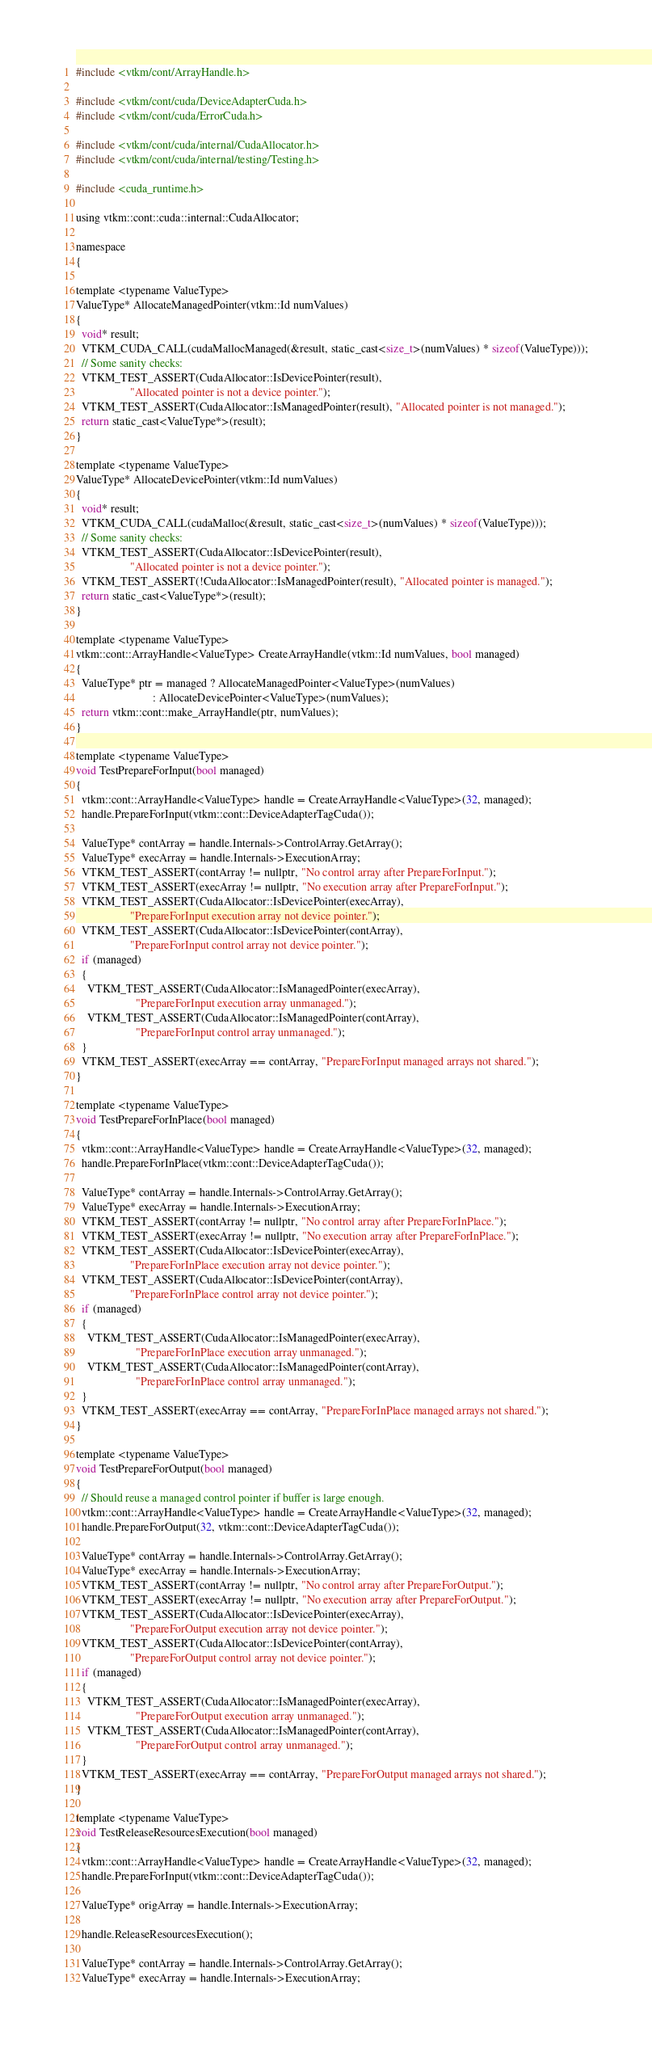Convert code to text. <code><loc_0><loc_0><loc_500><loc_500><_Cuda_>#include <vtkm/cont/ArrayHandle.h>

#include <vtkm/cont/cuda/DeviceAdapterCuda.h>
#include <vtkm/cont/cuda/ErrorCuda.h>

#include <vtkm/cont/cuda/internal/CudaAllocator.h>
#include <vtkm/cont/cuda/internal/testing/Testing.h>

#include <cuda_runtime.h>

using vtkm::cont::cuda::internal::CudaAllocator;

namespace
{

template <typename ValueType>
ValueType* AllocateManagedPointer(vtkm::Id numValues)
{
  void* result;
  VTKM_CUDA_CALL(cudaMallocManaged(&result, static_cast<size_t>(numValues) * sizeof(ValueType)));
  // Some sanity checks:
  VTKM_TEST_ASSERT(CudaAllocator::IsDevicePointer(result),
                   "Allocated pointer is not a device pointer.");
  VTKM_TEST_ASSERT(CudaAllocator::IsManagedPointer(result), "Allocated pointer is not managed.");
  return static_cast<ValueType*>(result);
}

template <typename ValueType>
ValueType* AllocateDevicePointer(vtkm::Id numValues)
{
  void* result;
  VTKM_CUDA_CALL(cudaMalloc(&result, static_cast<size_t>(numValues) * sizeof(ValueType)));
  // Some sanity checks:
  VTKM_TEST_ASSERT(CudaAllocator::IsDevicePointer(result),
                   "Allocated pointer is not a device pointer.");
  VTKM_TEST_ASSERT(!CudaAllocator::IsManagedPointer(result), "Allocated pointer is managed.");
  return static_cast<ValueType*>(result);
}

template <typename ValueType>
vtkm::cont::ArrayHandle<ValueType> CreateArrayHandle(vtkm::Id numValues, bool managed)
{
  ValueType* ptr = managed ? AllocateManagedPointer<ValueType>(numValues)
                           : AllocateDevicePointer<ValueType>(numValues);
  return vtkm::cont::make_ArrayHandle(ptr, numValues);
}

template <typename ValueType>
void TestPrepareForInput(bool managed)
{
  vtkm::cont::ArrayHandle<ValueType> handle = CreateArrayHandle<ValueType>(32, managed);
  handle.PrepareForInput(vtkm::cont::DeviceAdapterTagCuda());

  ValueType* contArray = handle.Internals->ControlArray.GetArray();
  ValueType* execArray = handle.Internals->ExecutionArray;
  VTKM_TEST_ASSERT(contArray != nullptr, "No control array after PrepareForInput.");
  VTKM_TEST_ASSERT(execArray != nullptr, "No execution array after PrepareForInput.");
  VTKM_TEST_ASSERT(CudaAllocator::IsDevicePointer(execArray),
                   "PrepareForInput execution array not device pointer.");
  VTKM_TEST_ASSERT(CudaAllocator::IsDevicePointer(contArray),
                   "PrepareForInput control array not device pointer.");
  if (managed)
  {
    VTKM_TEST_ASSERT(CudaAllocator::IsManagedPointer(execArray),
                     "PrepareForInput execution array unmanaged.");
    VTKM_TEST_ASSERT(CudaAllocator::IsManagedPointer(contArray),
                     "PrepareForInput control array unmanaged.");
  }
  VTKM_TEST_ASSERT(execArray == contArray, "PrepareForInput managed arrays not shared.");
}

template <typename ValueType>
void TestPrepareForInPlace(bool managed)
{
  vtkm::cont::ArrayHandle<ValueType> handle = CreateArrayHandle<ValueType>(32, managed);
  handle.PrepareForInPlace(vtkm::cont::DeviceAdapterTagCuda());

  ValueType* contArray = handle.Internals->ControlArray.GetArray();
  ValueType* execArray = handle.Internals->ExecutionArray;
  VTKM_TEST_ASSERT(contArray != nullptr, "No control array after PrepareForInPlace.");
  VTKM_TEST_ASSERT(execArray != nullptr, "No execution array after PrepareForInPlace.");
  VTKM_TEST_ASSERT(CudaAllocator::IsDevicePointer(execArray),
                   "PrepareForInPlace execution array not device pointer.");
  VTKM_TEST_ASSERT(CudaAllocator::IsDevicePointer(contArray),
                   "PrepareForInPlace control array not device pointer.");
  if (managed)
  {
    VTKM_TEST_ASSERT(CudaAllocator::IsManagedPointer(execArray),
                     "PrepareForInPlace execution array unmanaged.");
    VTKM_TEST_ASSERT(CudaAllocator::IsManagedPointer(contArray),
                     "PrepareForInPlace control array unmanaged.");
  }
  VTKM_TEST_ASSERT(execArray == contArray, "PrepareForInPlace managed arrays not shared.");
}

template <typename ValueType>
void TestPrepareForOutput(bool managed)
{
  // Should reuse a managed control pointer if buffer is large enough.
  vtkm::cont::ArrayHandle<ValueType> handle = CreateArrayHandle<ValueType>(32, managed);
  handle.PrepareForOutput(32, vtkm::cont::DeviceAdapterTagCuda());

  ValueType* contArray = handle.Internals->ControlArray.GetArray();
  ValueType* execArray = handle.Internals->ExecutionArray;
  VTKM_TEST_ASSERT(contArray != nullptr, "No control array after PrepareForOutput.");
  VTKM_TEST_ASSERT(execArray != nullptr, "No execution array after PrepareForOutput.");
  VTKM_TEST_ASSERT(CudaAllocator::IsDevicePointer(execArray),
                   "PrepareForOutput execution array not device pointer.");
  VTKM_TEST_ASSERT(CudaAllocator::IsDevicePointer(contArray),
                   "PrepareForOutput control array not device pointer.");
  if (managed)
  {
    VTKM_TEST_ASSERT(CudaAllocator::IsManagedPointer(execArray),
                     "PrepareForOutput execution array unmanaged.");
    VTKM_TEST_ASSERT(CudaAllocator::IsManagedPointer(contArray),
                     "PrepareForOutput control array unmanaged.");
  }
  VTKM_TEST_ASSERT(execArray == contArray, "PrepareForOutput managed arrays not shared.");
}

template <typename ValueType>
void TestReleaseResourcesExecution(bool managed)
{
  vtkm::cont::ArrayHandle<ValueType> handle = CreateArrayHandle<ValueType>(32, managed);
  handle.PrepareForInput(vtkm::cont::DeviceAdapterTagCuda());

  ValueType* origArray = handle.Internals->ExecutionArray;

  handle.ReleaseResourcesExecution();

  ValueType* contArray = handle.Internals->ControlArray.GetArray();
  ValueType* execArray = handle.Internals->ExecutionArray;
</code> 